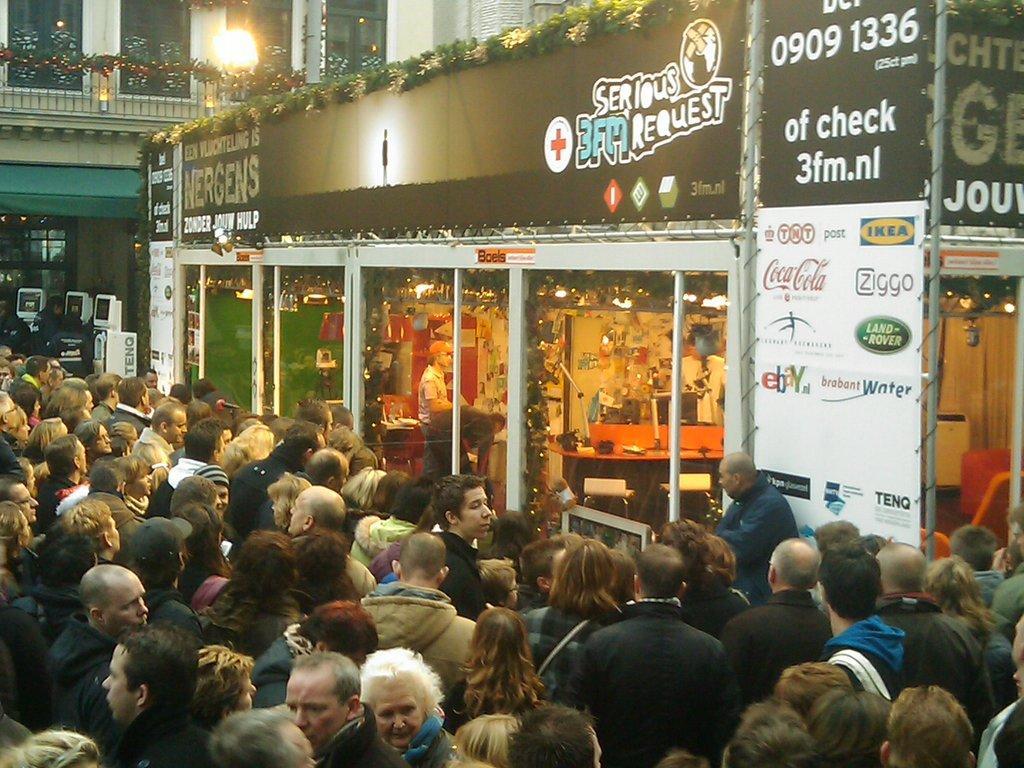Could you give a brief overview of what you see in this image? In this picture there are few persons standing in front of a store which has something written on it and there is a light and a building in the background. 